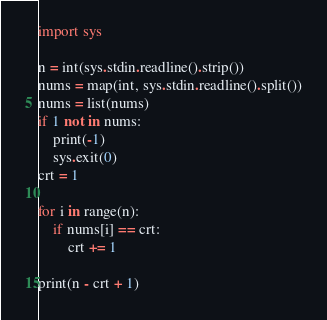<code> <loc_0><loc_0><loc_500><loc_500><_Python_>import sys

n = int(sys.stdin.readline().strip())
nums = map(int, sys.stdin.readline().split())
nums = list(nums)
if 1 not in nums:
    print(-1)
    sys.exit(0)
crt = 1

for i in range(n):
    if nums[i] == crt:
        crt += 1
    
print(n - crt + 1)</code> 